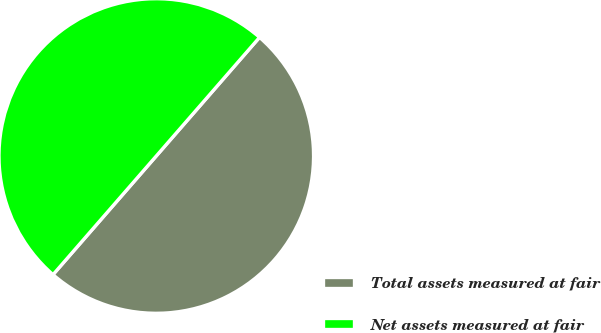<chart> <loc_0><loc_0><loc_500><loc_500><pie_chart><fcel>Total assets measured at fair<fcel>Net assets measured at fair<nl><fcel>50.0%<fcel>50.0%<nl></chart> 